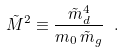Convert formula to latex. <formula><loc_0><loc_0><loc_500><loc_500>\tilde { M } ^ { 2 } \equiv \frac { \tilde { m } _ { d } ^ { 4 } } { m _ { 0 } \, \tilde { m } _ { g } } \ .</formula> 